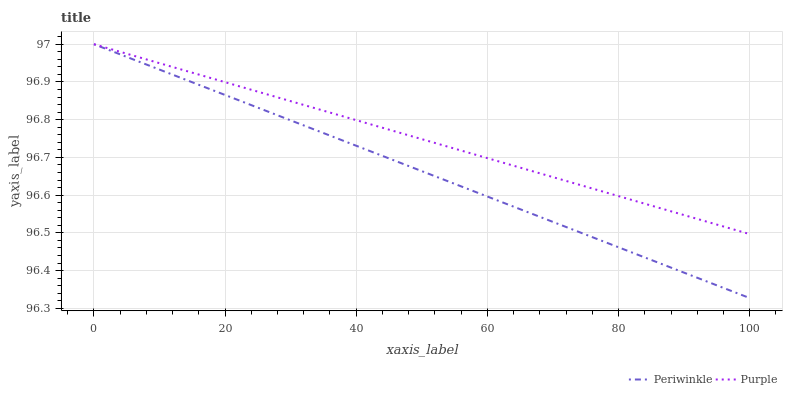Does Periwinkle have the minimum area under the curve?
Answer yes or no. Yes. Does Purple have the maximum area under the curve?
Answer yes or no. Yes. Does Periwinkle have the maximum area under the curve?
Answer yes or no. No. Is Purple the smoothest?
Answer yes or no. Yes. Is Periwinkle the roughest?
Answer yes or no. Yes. Is Periwinkle the smoothest?
Answer yes or no. No. Does Periwinkle have the lowest value?
Answer yes or no. Yes. Does Periwinkle have the highest value?
Answer yes or no. Yes. Does Periwinkle intersect Purple?
Answer yes or no. Yes. Is Periwinkle less than Purple?
Answer yes or no. No. Is Periwinkle greater than Purple?
Answer yes or no. No. 